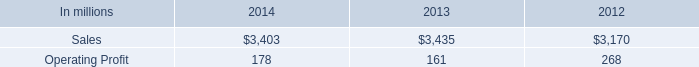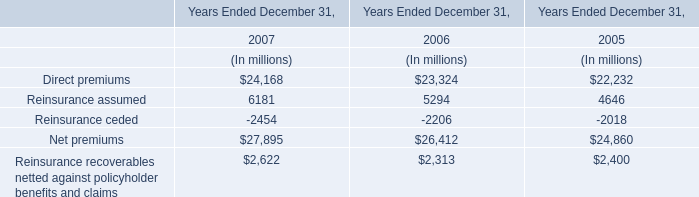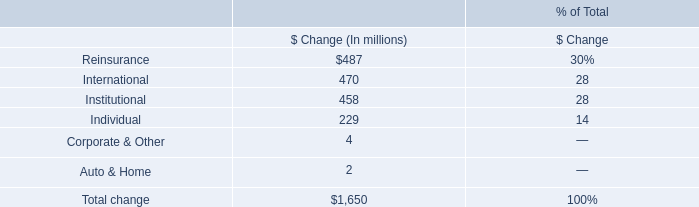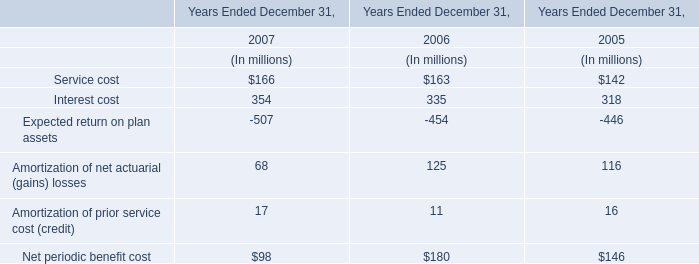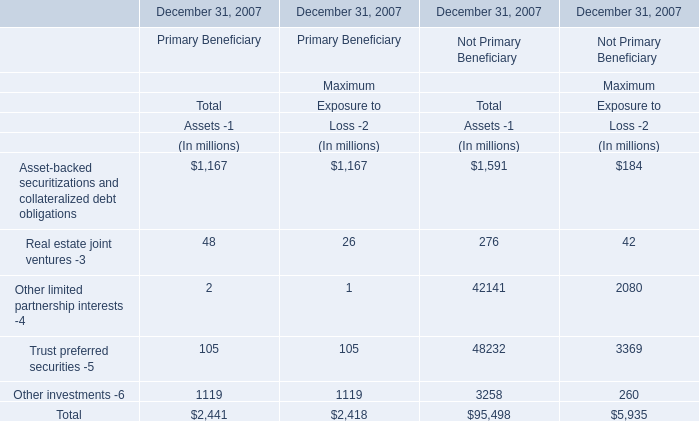what percentage where north american consumer packaging net sales of consumer packaging sales in 2013? 
Computations: ((2 * 1000) / 3435)
Answer: 0.58224. 